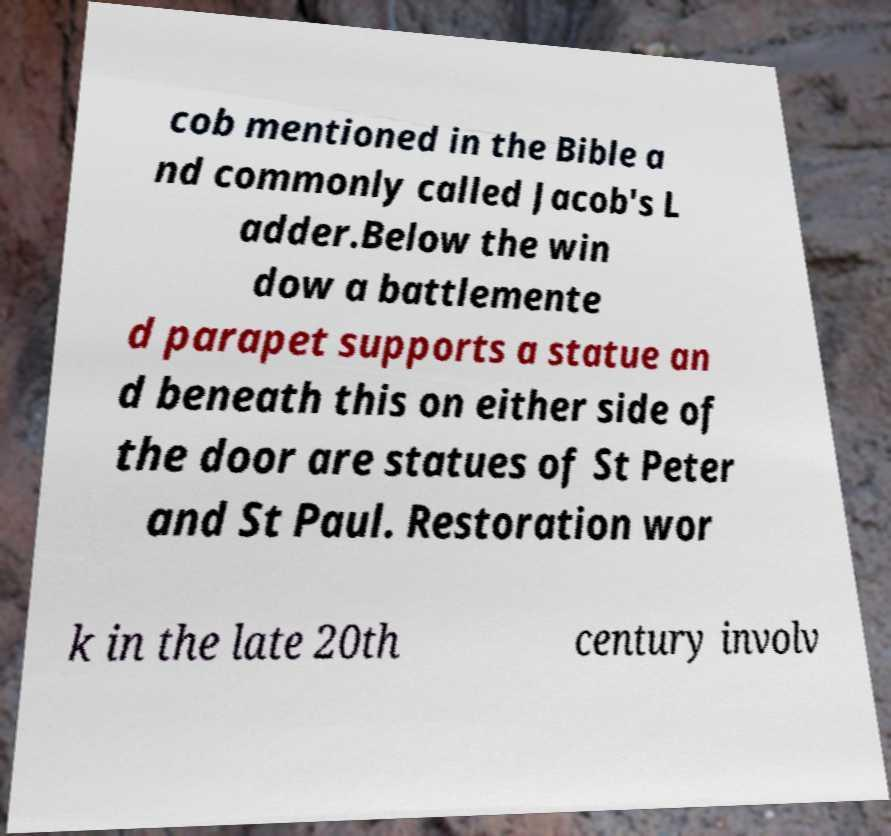For documentation purposes, I need the text within this image transcribed. Could you provide that? cob mentioned in the Bible a nd commonly called Jacob's L adder.Below the win dow a battlemente d parapet supports a statue an d beneath this on either side of the door are statues of St Peter and St Paul. Restoration wor k in the late 20th century involv 